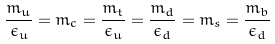<formula> <loc_0><loc_0><loc_500><loc_500>\frac { m _ { u } } { \epsilon _ { u } } = m _ { c } = \frac { m _ { t } } { \epsilon _ { u } } = \frac { m _ { d } } { \epsilon _ { d } } = m _ { s } = \frac { m _ { b } } { \epsilon _ { d } }</formula> 